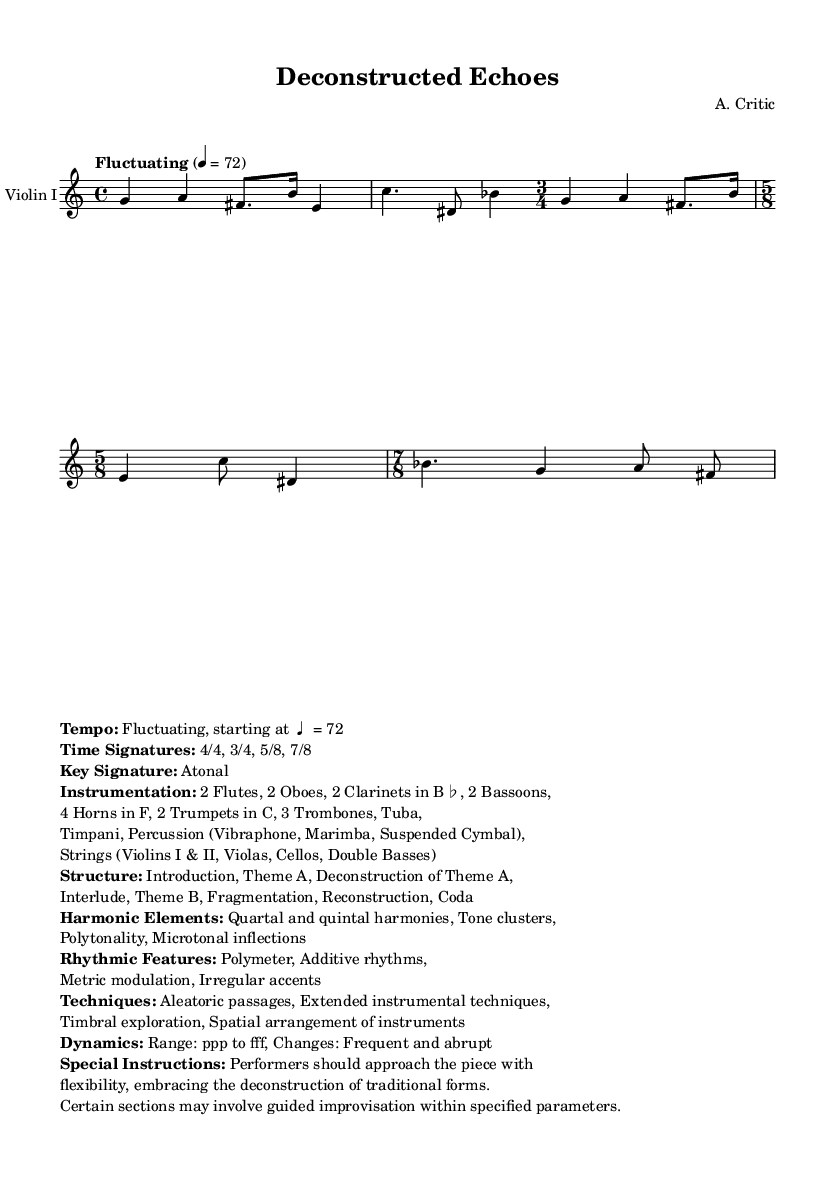What is the title of the symphony? The title appears at the beginning of the sheet music in the header section labeled as "title."
Answer: Deconstructed Echoes What is the key signature of this music? The key signature is explicitly noted in the markup section, where it states "Atonal." This means there is no specific key signature applied to the piece.
Answer: Atonal What is the tempo marking indicated in the score? The tempo marking is found in the global section labeled "tempo," where it is specified as "Fluctuating 4 = 72." This indicates a flexible tempo starting at the quarter note equal to 72 beats per minute.
Answer: Fluctuating, 4 = 72 How many different time signatures are used in this symphony? By reviewing the score section, we note the time signatures used: 4/4, 3/4, 5/8, and 7/8. Counting these gives us a total of four distinct time signatures.
Answer: 4 What are the bass instruments included in the instrumentation? The instruments are listed in the markup section. The relevant bass instruments are the 2 Bassoons, Tuba, and Strings (with Double Basses).
Answer: 2 Bassoons, Tuba, Double Basses What is the overall structure of the symphony? The structure can be found in the markup section, where it outlines the parts of the piece: Introduction, Theme A, Deconstruction of Theme A, Interlude, Theme B, Fragmentation, Reconstruction, Coda. This gives a clear order of sections.
Answer: Introduction, Theme A, Deconstruction of Theme A, Interlude, Theme B, Fragmentation, Reconstruction, Coda What dynamic range is specified in the symphony? The dynamics are noted in the markup section where it states: "Range: ppp to fff, Changes: Frequent and abrupt." This indicates a broad dynamic spectrum from very soft to very loud, with changes occurring often.
Answer: ppp to fff 